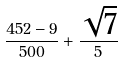<formula> <loc_0><loc_0><loc_500><loc_500>\frac { 4 5 2 - 9 } { 5 0 0 } + \frac { \sqrt { 7 } } { 5 }</formula> 